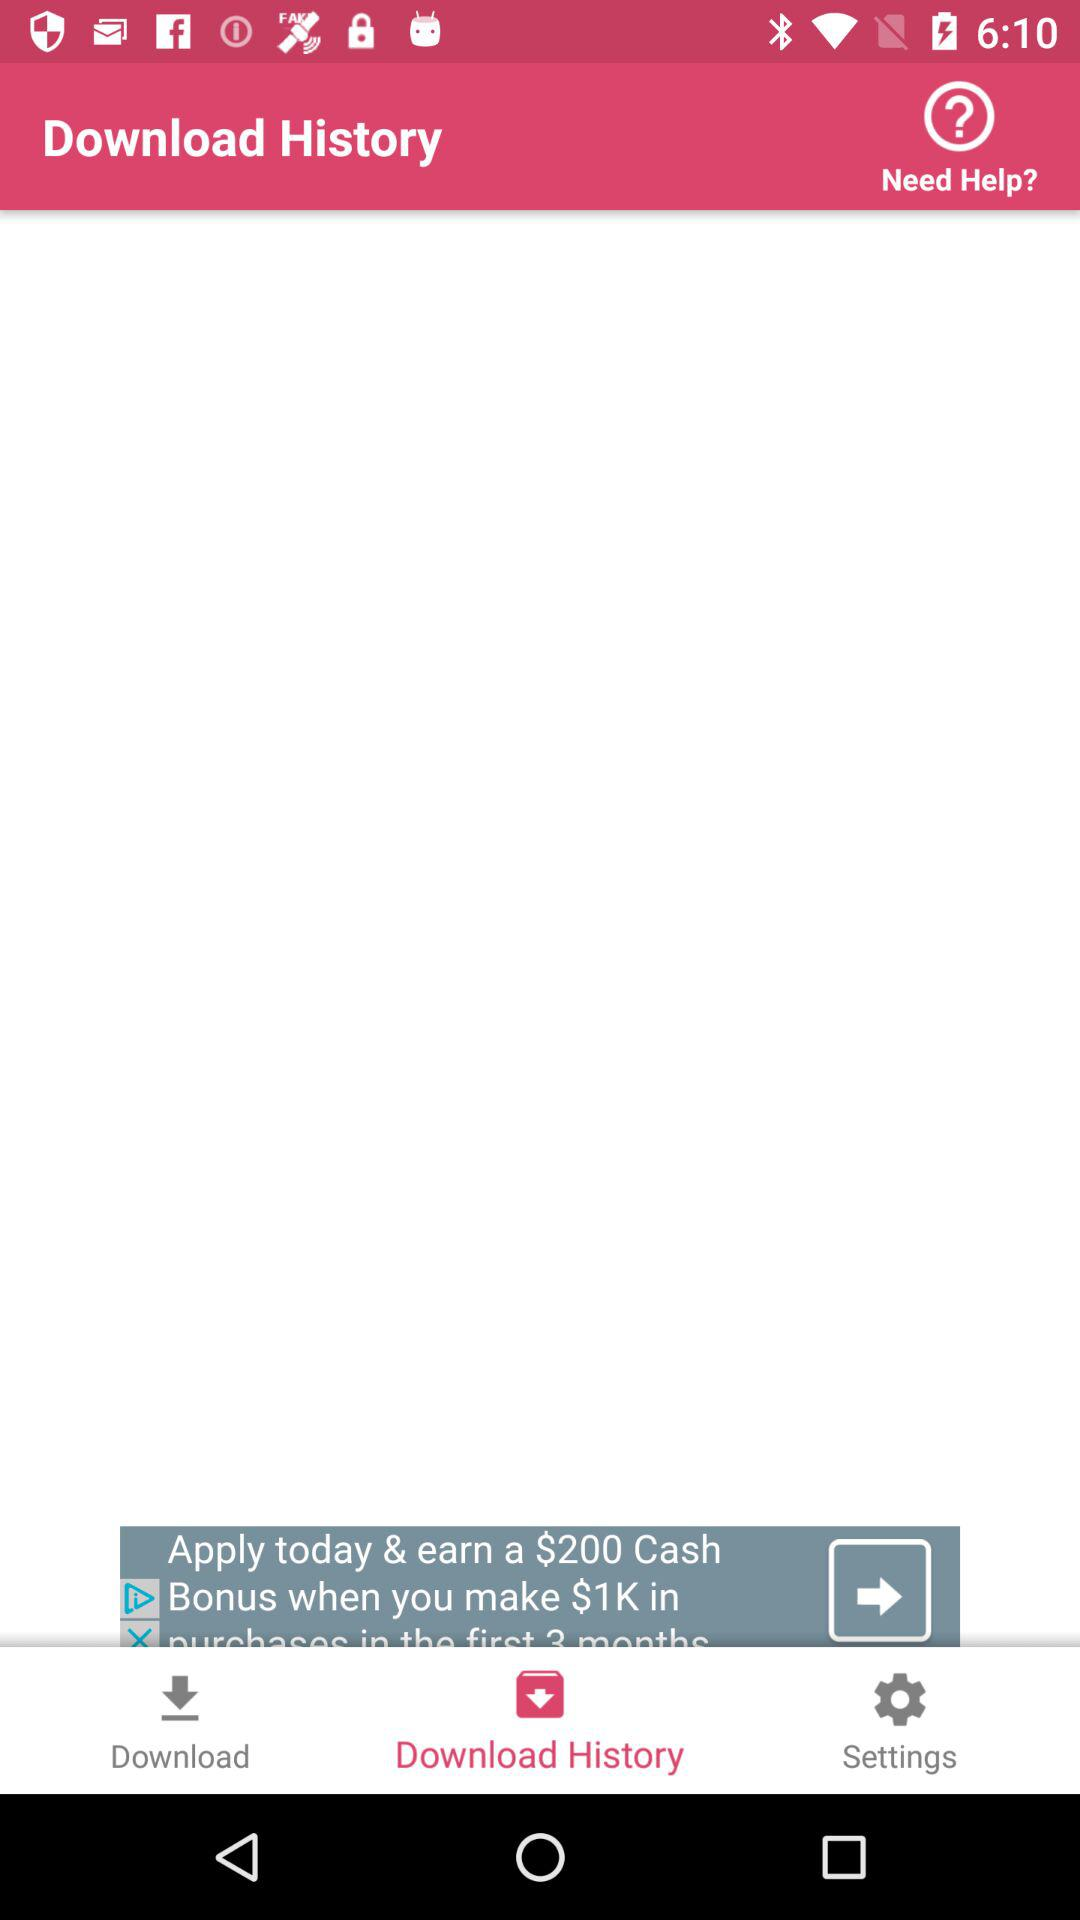What tab is selected? The selected tab is "Download History". 